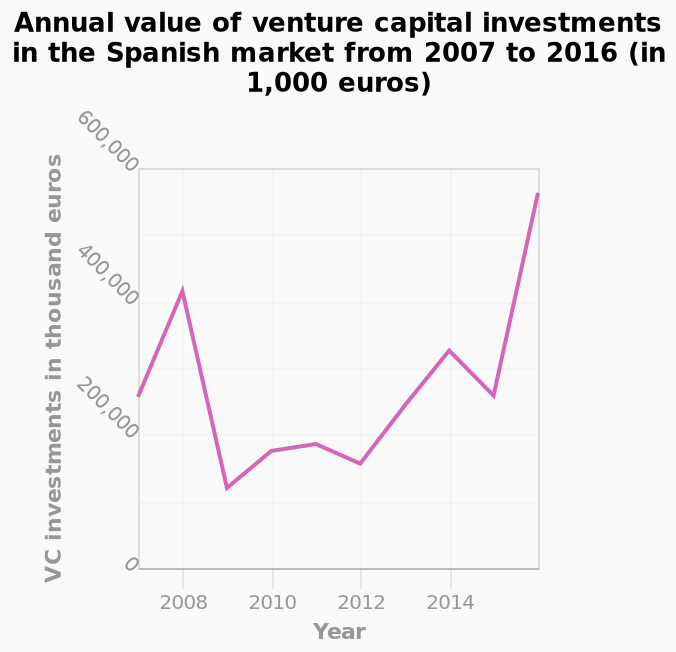<image>
What is the unit of measurement for the y-axis? The unit of measurement for the y-axis is thousand euros. How would you describe the variability in the value of investments during this period? There was a large amount of variability in the value of investments during this period, indicating fluctuations and changes in the investment values. What does the line graph represent? The line graph represents the annual value of venture capital investments in the Spanish market from 2007 to 2016. please summary the statistics and relations of the chart The value of investments has increased over the period of 2007 to 2016. In 2007 investments were valued at 300m EUR while in 2016 they were valued at nearly 600m EUR. This is an increase of 100% over this period. The value of investments was lowest in 2009 at 100m EUR. The value of investments was highest in 2016. There is a large amount of variability in the value of investments during this period. What is the maximum value on the y-axis? The maximum value on the y-axis is 600,000. When was the lowest value of investments recorded?  The lowest value of investments was recorded in 2009, at 100m EUR. When was the highest value of investments recorded?  The highest value of investments was recorded in 2016. 